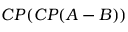<formula> <loc_0><loc_0><loc_500><loc_500>C P ( C P ( A - B ) )</formula> 